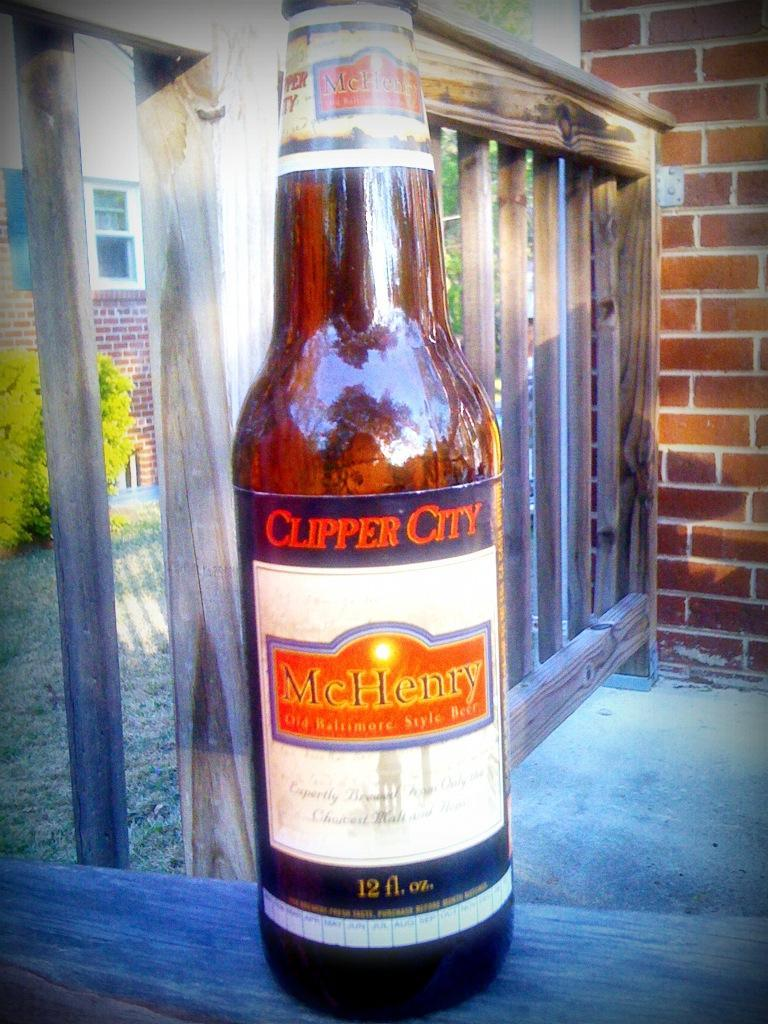What is on the bottle that is visible in the image? There is a sticker on the bottle in the image. Where is the bottle placed in the image? The bottle is placed on a wooden plank in the image. What can be seen in the background of the image? There is a tree, a wall, a window, and a wooden fence visible in the background of the image. What type of soup is being served in the wooden bowl in the image? There is no wooden bowl or soup present in the image; it only features a bottle with a sticker placed on a wooden plank. 